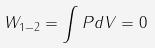Convert formula to latex. <formula><loc_0><loc_0><loc_500><loc_500>W _ { 1 - 2 } = \int P d V = 0</formula> 